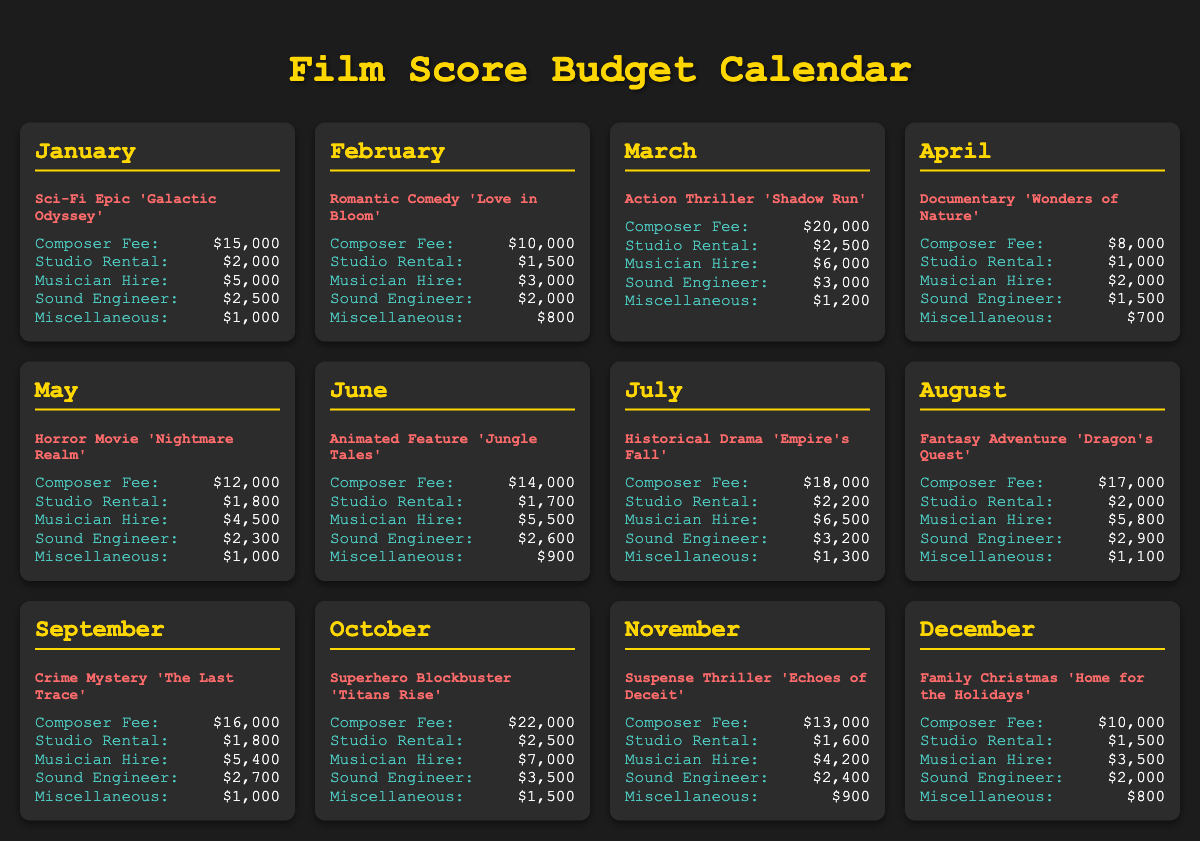What is the total composer fee for January? The total composer fee for January is the specific amount listed in the document for the project 'Galactic Odyssey,' which is $15,000.
Answer: $15,000 What film genre is 'Love in Bloom'? The genre for 'Love in Bloom' is stated in the document as a Romantic Comedy.
Answer: Romantic Comedy Which month has the highest composer fee? To determine the month with the highest composer fee, we compare all the fees listed, with October's fee of $22,000 being the highest.
Answer: October What is the total expense for 'Echoes of Deceit'? The total expenses for 'Echoes of Deceit' are calculated by summing all defined expenses: $13,000 + $1,600 + $4,200 + $2,400 + $900, which equals $22,100.
Answer: $22,100 Which project has a studio rental cost of $1,500? The project with a studio rental cost of $1,500 is identified in the document as 'Home for the Holidays'.
Answer: Home for the Holidays What is the miscellaneous expense for 'Empire's Fall'? The miscellaneous expense for 'Empire's Fall' is specifically listed in the document as $1,300.
Answer: $1,300 How many projects have a composer fee above $15,000? To find the number of projects with a composer fee above $15,000, we check the fees: 'Shadow Run', 'Titans Rise', and 'Empire's Fall' exceed this amount, totaling three projects.
Answer: 3 What is the studio rental cost for 'Jungle Tales'? The studio rental cost for 'Jungle Tales' is directly mentioned in the document as $1,700.
Answer: $1,700 Which project has the lowest composer fee? The project with the lowest composer fee is 'Wonders of Nature', which is stated as $8,000.
Answer: Wonders of Nature 